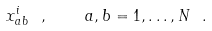Convert formula to latex. <formula><loc_0><loc_0><loc_500><loc_500>x _ { a b } ^ { i } \ , \quad a , b = 1 , \dots , N \ .</formula> 